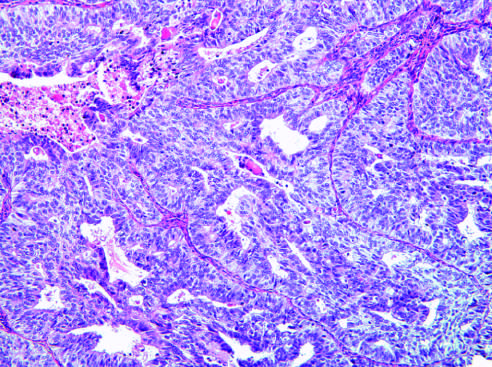what has a predominantly solid growth pattern?
Answer the question using a single word or phrase. Endometrioid type 